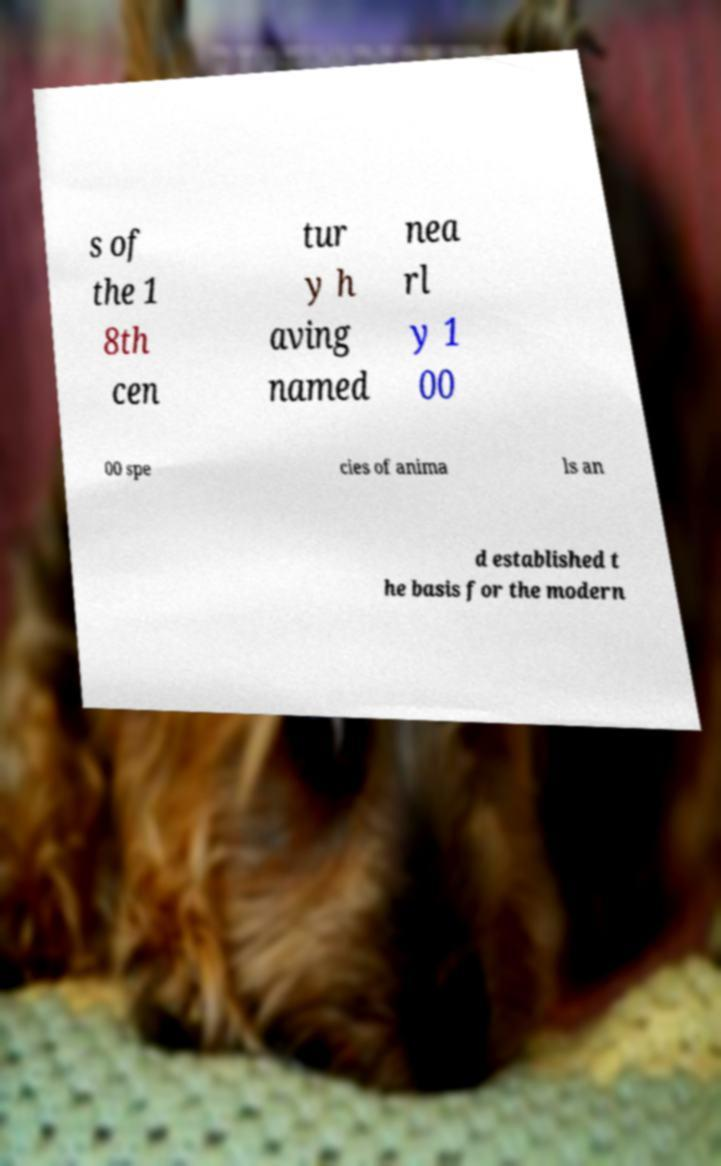Can you accurately transcribe the text from the provided image for me? s of the 1 8th cen tur y h aving named nea rl y 1 00 00 spe cies of anima ls an d established t he basis for the modern 